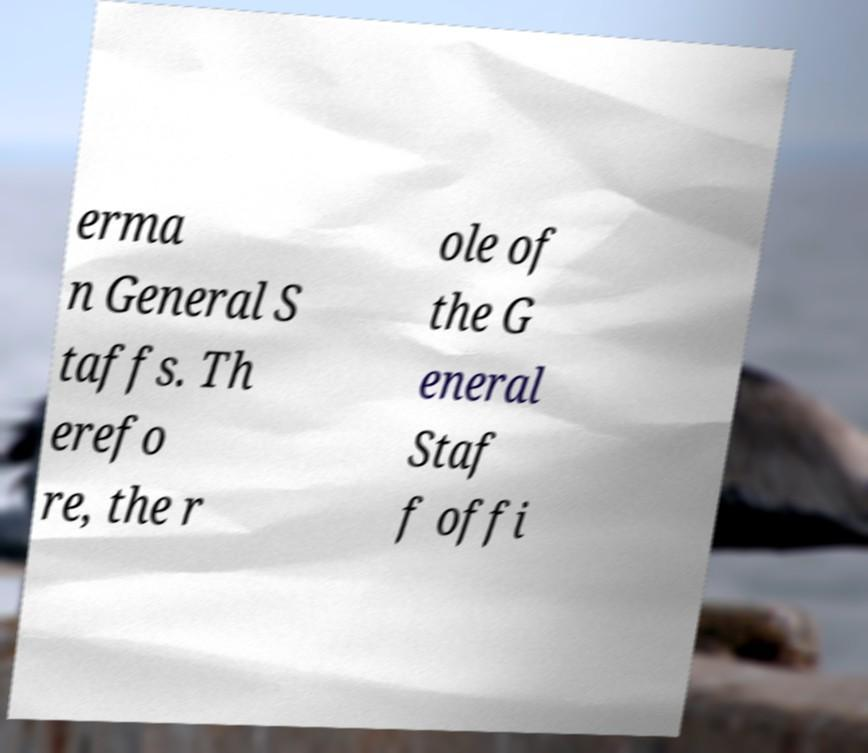Please read and relay the text visible in this image. What does it say? erma n General S taffs. Th erefo re, the r ole of the G eneral Staf f offi 